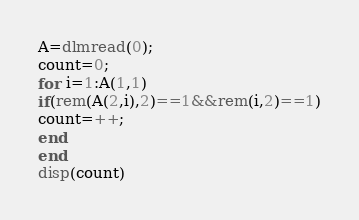Convert code to text. <code><loc_0><loc_0><loc_500><loc_500><_Octave_>A=dlmread(0);
count=0;
for i=1:A(1,1)
if(rem(A(2,i),2)==1&&rem(i,2)==1)
count=++;
end
end
disp(count)</code> 